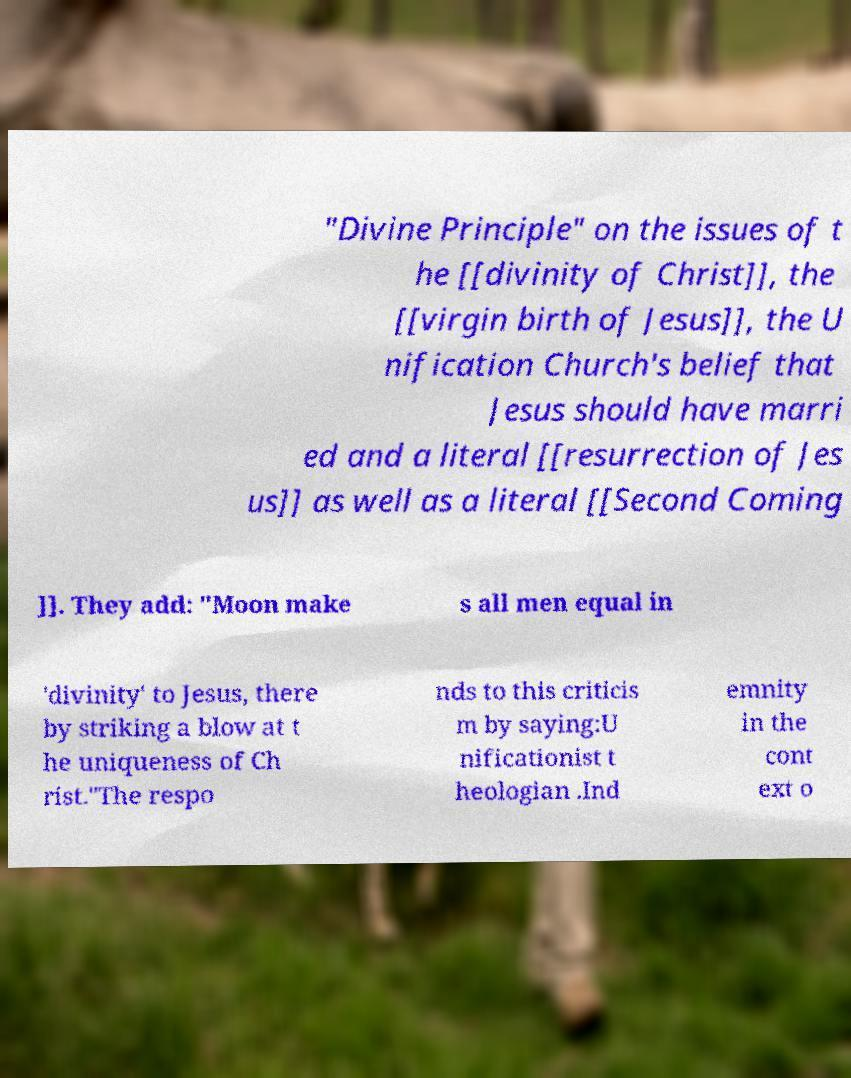Can you accurately transcribe the text from the provided image for me? "Divine Principle" on the issues of t he [[divinity of Christ]], the [[virgin birth of Jesus]], the U nification Church's belief that Jesus should have marri ed and a literal [[resurrection of Jes us]] as well as a literal [[Second Coming ]]. They add: "Moon make s all men equal in 'divinity' to Jesus, there by striking a blow at t he uniqueness of Ch rist."The respo nds to this criticis m by saying:U nificationist t heologian .Ind emnity in the cont ext o 